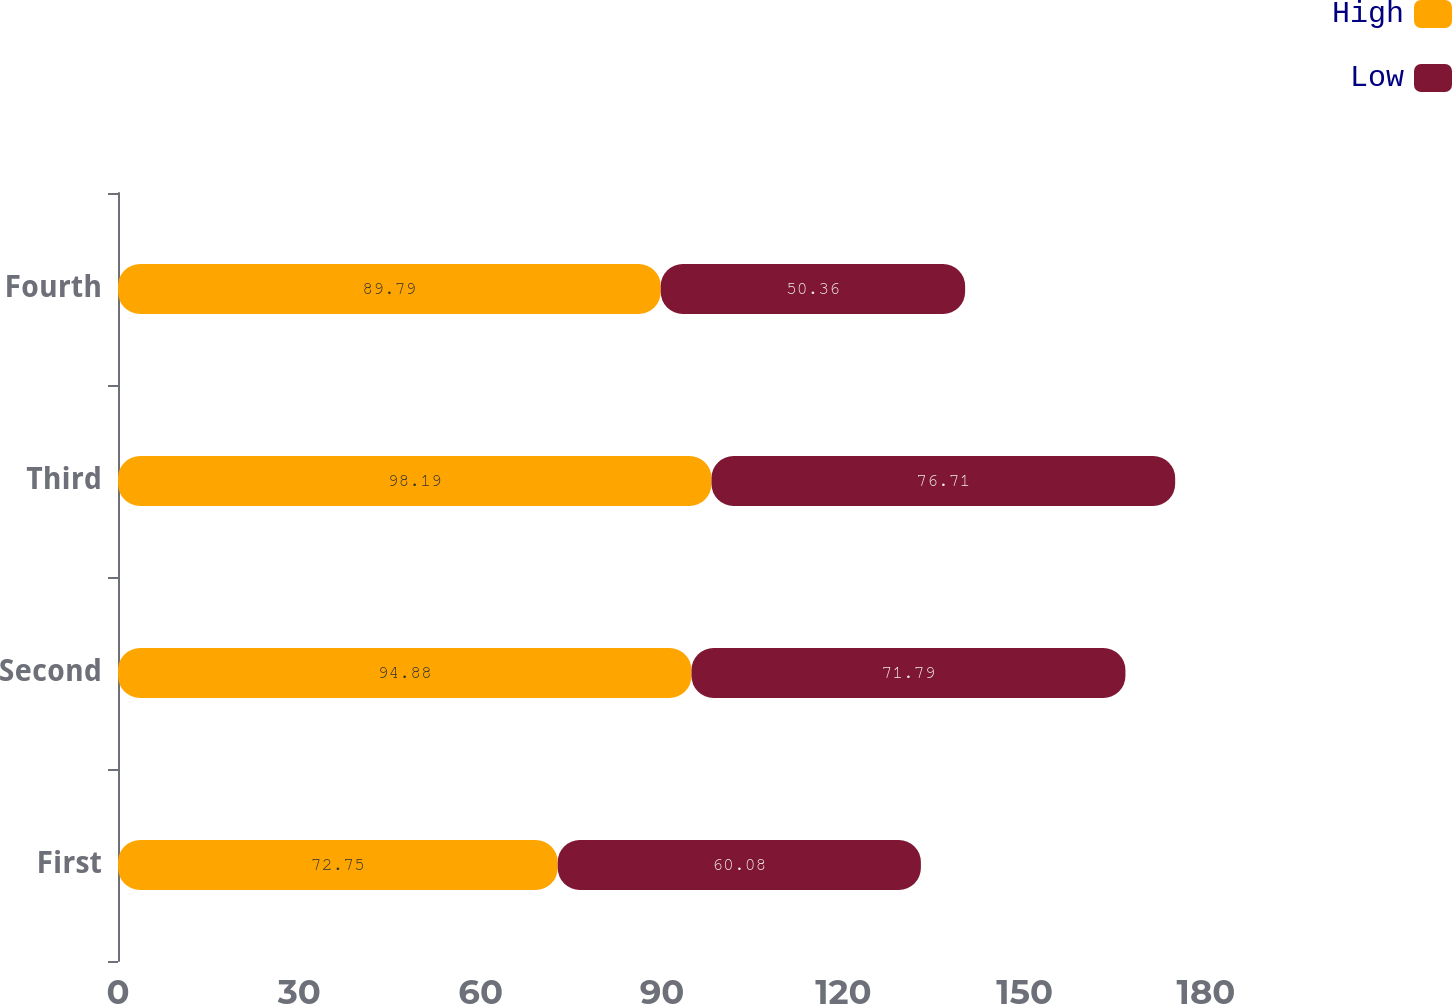Convert chart to OTSL. <chart><loc_0><loc_0><loc_500><loc_500><stacked_bar_chart><ecel><fcel>First<fcel>Second<fcel>Third<fcel>Fourth<nl><fcel>High<fcel>72.75<fcel>94.88<fcel>98.19<fcel>89.79<nl><fcel>Low<fcel>60.08<fcel>71.79<fcel>76.71<fcel>50.36<nl></chart> 